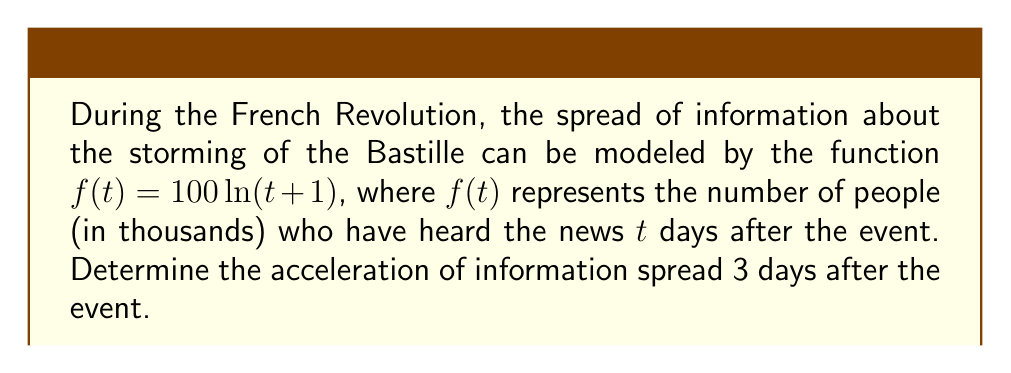Can you solve this math problem? To find the acceleration of information spread, we need to calculate the second derivative of the given function $f(t)$ and evaluate it at $t=3$.

Step 1: Find the first derivative.
$$f'(t) = \frac{d}{dt}[100\ln(t+1)] = \frac{100}{t+1}$$

Step 2: Find the second derivative (acceleration).
$$f''(t) = \frac{d}{dt}[\frac{100}{t+1}] = -\frac{100}{(t+1)^2}$$

Step 3: Evaluate the second derivative at $t=3$.
$$f''(3) = -\frac{100}{(3+1)^2} = -\frac{100}{16} = -6.25$$

The negative value indicates that the acceleration is decreasing, which aligns with the historical perspective that information spread would slow down over time as more people become aware of the event.
Answer: $-6.25$ thousand people/day² 